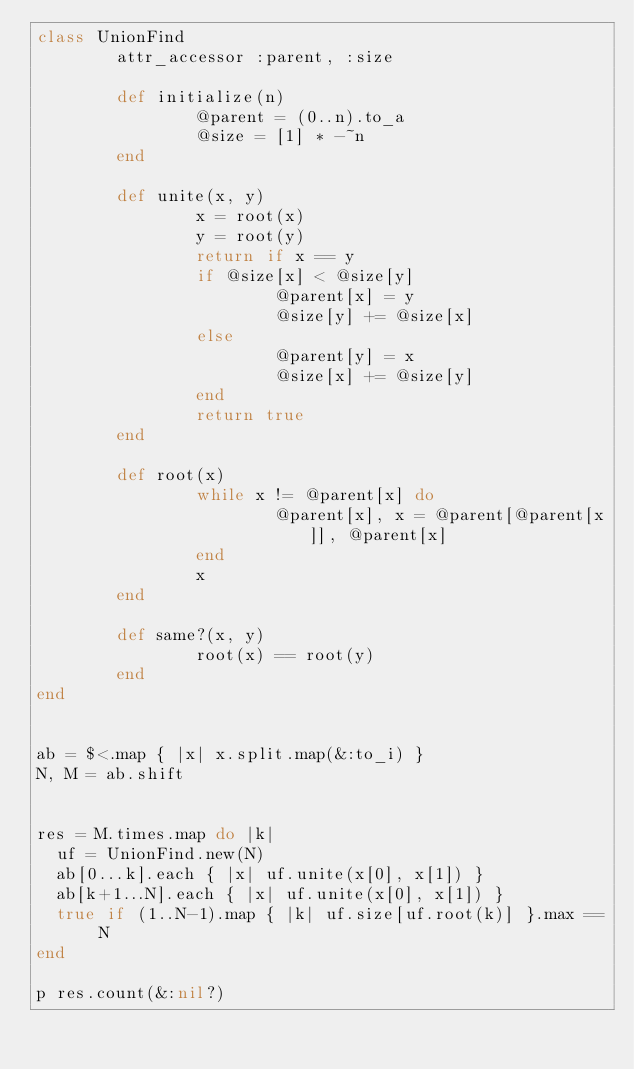Convert code to text. <code><loc_0><loc_0><loc_500><loc_500><_Ruby_>class UnionFind
        attr_accessor :parent, :size

        def initialize(n)
                @parent = (0..n).to_a
                @size = [1] * -~n
        end
	
        def unite(x, y)
                x = root(x)
                y = root(y)
                return if x == y
                if @size[x] < @size[y]
                        @parent[x] = y
                        @size[y] += @size[x]
                else
                        @parent[y] = x
                        @size[x] += @size[y]
                end
                return true
        end

        def root(x)
                while x != @parent[x] do
                        @parent[x], x = @parent[@parent[x]], @parent[x]
                end
                x
        end

        def same?(x, y)
                root(x) == root(y)
        end
end


ab = $<.map { |x| x.split.map(&:to_i) }
N, M = ab.shift


res = M.times.map do |k|
	uf = UnionFind.new(N)
	ab[0...k].each { |x| uf.unite(x[0], x[1]) }
	ab[k+1...N].each { |x| uf.unite(x[0], x[1]) }
	true if	(1..N-1).map { |k| uf.size[uf.root(k)] }.max == N
end

p res.count(&:nil?)
</code> 